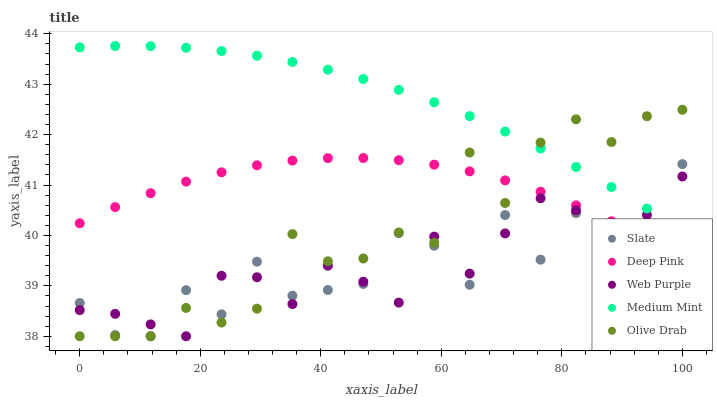Does Slate have the minimum area under the curve?
Answer yes or no. Yes. Does Medium Mint have the maximum area under the curve?
Answer yes or no. Yes. Does Deep Pink have the minimum area under the curve?
Answer yes or no. No. Does Deep Pink have the maximum area under the curve?
Answer yes or no. No. Is Medium Mint the smoothest?
Answer yes or no. Yes. Is Slate the roughest?
Answer yes or no. Yes. Is Deep Pink the smoothest?
Answer yes or no. No. Is Deep Pink the roughest?
Answer yes or no. No. Does Slate have the lowest value?
Answer yes or no. Yes. Does Deep Pink have the lowest value?
Answer yes or no. No. Does Medium Mint have the highest value?
Answer yes or no. Yes. Does Slate have the highest value?
Answer yes or no. No. Is Deep Pink less than Medium Mint?
Answer yes or no. Yes. Is Medium Mint greater than Deep Pink?
Answer yes or no. Yes. Does Deep Pink intersect Slate?
Answer yes or no. Yes. Is Deep Pink less than Slate?
Answer yes or no. No. Is Deep Pink greater than Slate?
Answer yes or no. No. Does Deep Pink intersect Medium Mint?
Answer yes or no. No. 